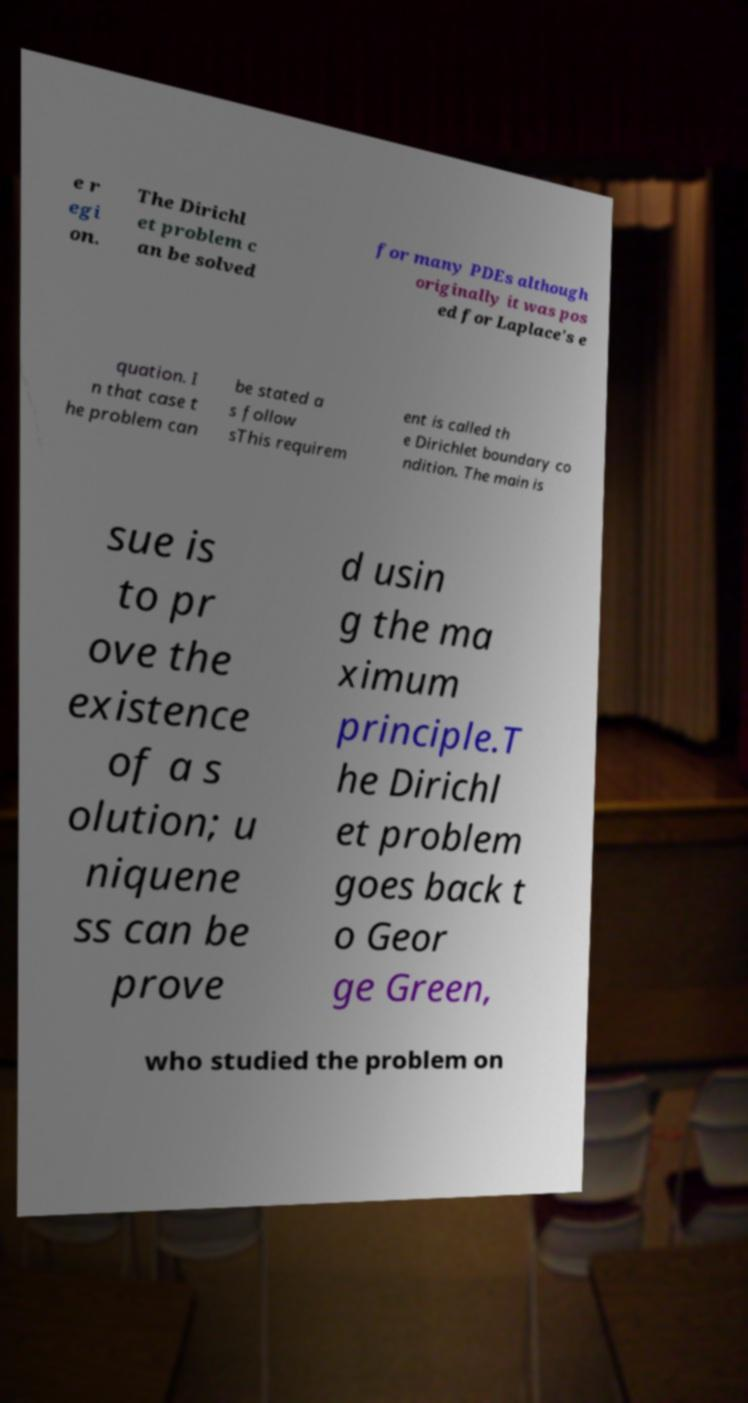Can you accurately transcribe the text from the provided image for me? e r egi on. The Dirichl et problem c an be solved for many PDEs although originally it was pos ed for Laplace's e quation. I n that case t he problem can be stated a s follow sThis requirem ent is called th e Dirichlet boundary co ndition. The main is sue is to pr ove the existence of a s olution; u niquene ss can be prove d usin g the ma ximum principle.T he Dirichl et problem goes back t o Geor ge Green, who studied the problem on 